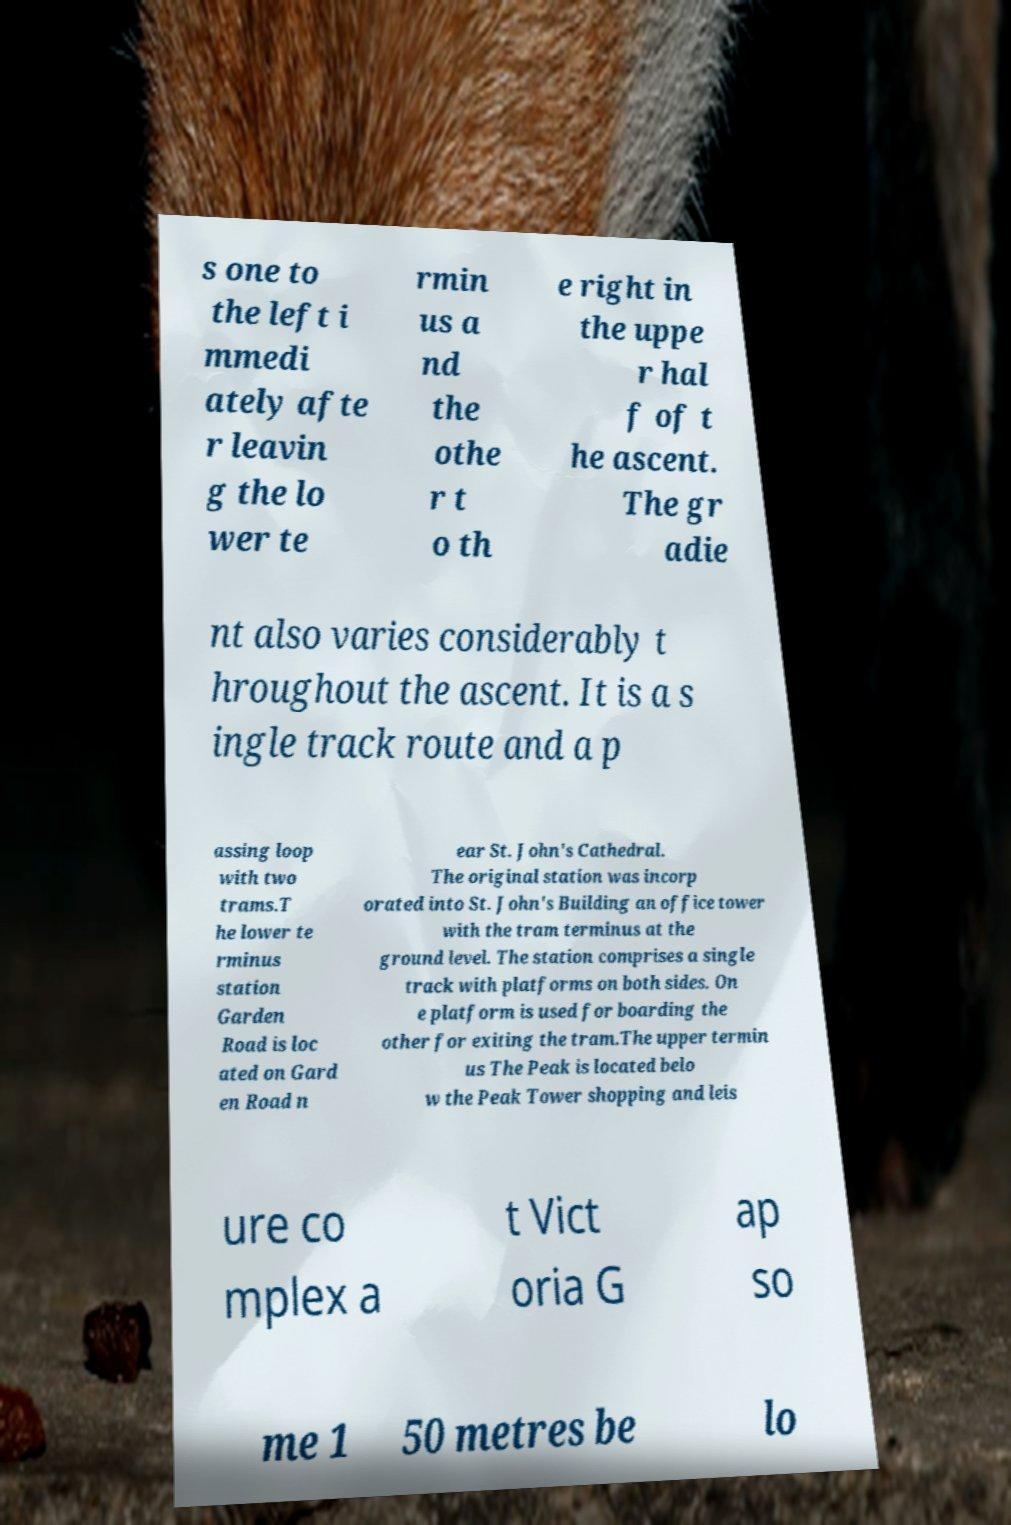There's text embedded in this image that I need extracted. Can you transcribe it verbatim? s one to the left i mmedi ately afte r leavin g the lo wer te rmin us a nd the othe r t o th e right in the uppe r hal f of t he ascent. The gr adie nt also varies considerably t hroughout the ascent. It is a s ingle track route and a p assing loop with two trams.T he lower te rminus station Garden Road is loc ated on Gard en Road n ear St. John's Cathedral. The original station was incorp orated into St. John's Building an office tower with the tram terminus at the ground level. The station comprises a single track with platforms on both sides. On e platform is used for boarding the other for exiting the tram.The upper termin us The Peak is located belo w the Peak Tower shopping and leis ure co mplex a t Vict oria G ap so me 1 50 metres be lo 